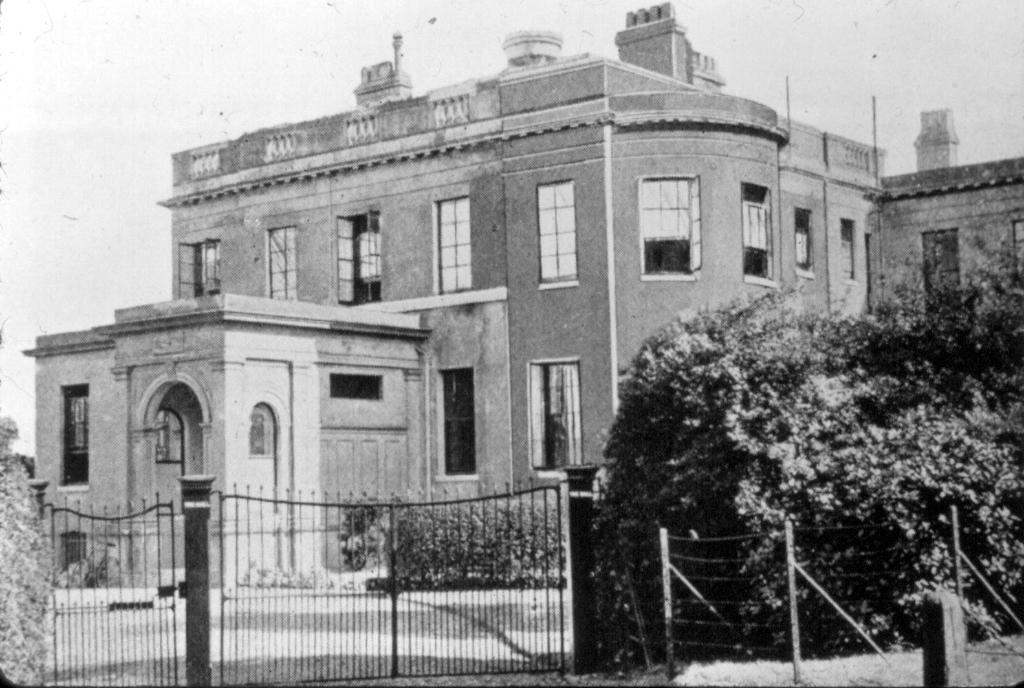What type of structures can be seen in the image? There are buildings in the image. What architectural features can be observed on the buildings? There are windows visible on the buildings. What type of vegetation is present in the image? There are trees in the image. What is the entrance to the area like? There is a gate in the image. What can be seen above the buildings and trees? The sky is visible in the image. Can you tell me how many flowers are growing near the gate in the image? There are no flowers visible in the image; it features buildings, windows, trees, a gate, and the sky. Is there a giraffe visible in the image? No, there is no giraffe present in the image. 